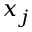<formula> <loc_0><loc_0><loc_500><loc_500>x _ { j }</formula> 